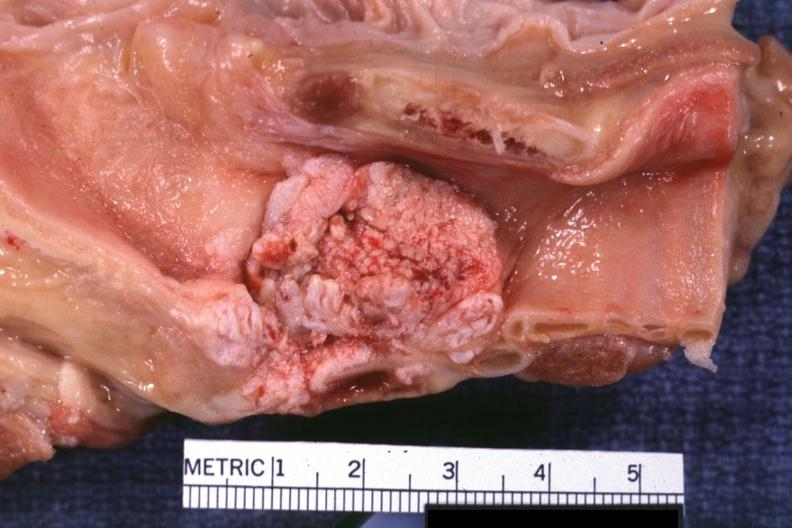what is present?
Answer the question using a single word or phrase. Larynx 